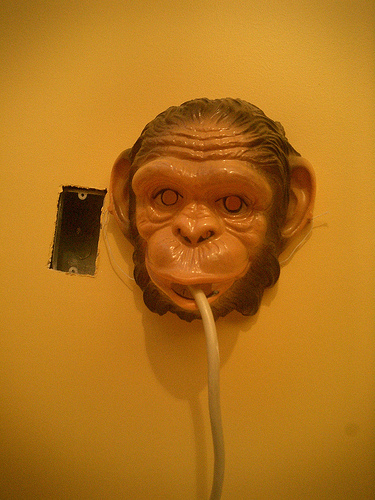<image>
Is the monkey on the wall? Yes. Looking at the image, I can see the monkey is positioned on top of the wall, with the wall providing support. Is the monkey head on the wall? Yes. Looking at the image, I can see the monkey head is positioned on top of the wall, with the wall providing support. 